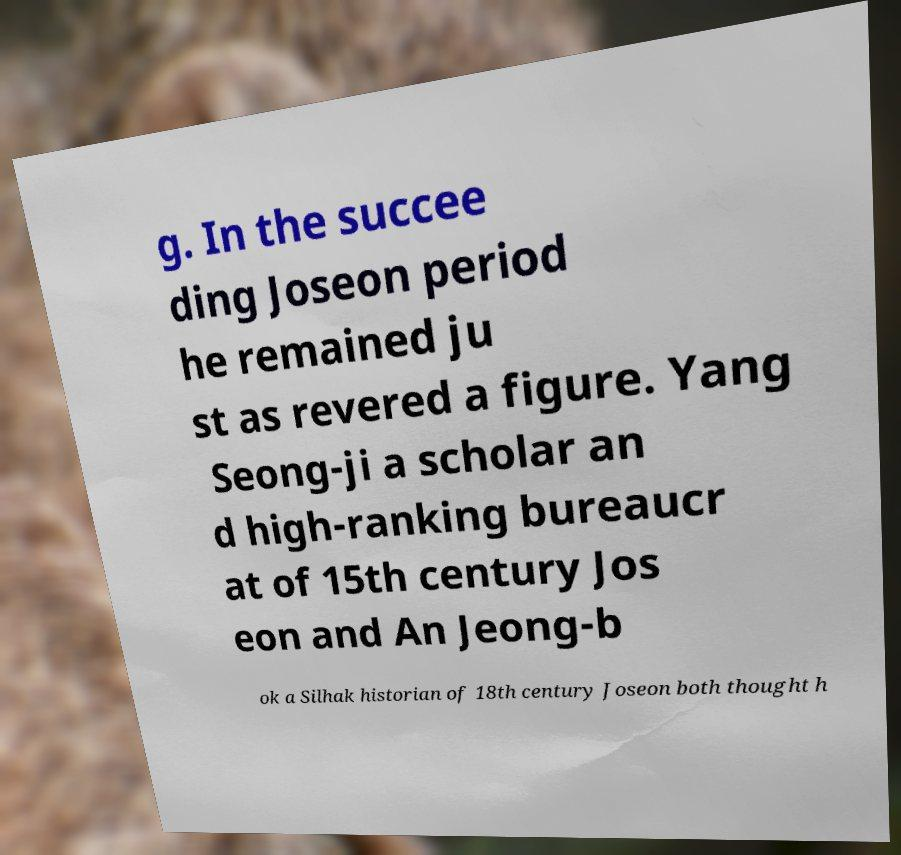Can you read and provide the text displayed in the image?This photo seems to have some interesting text. Can you extract and type it out for me? g. In the succee ding Joseon period he remained ju st as revered a figure. Yang Seong-ji a scholar an d high-ranking bureaucr at of 15th century Jos eon and An Jeong-b ok a Silhak historian of 18th century Joseon both thought h 